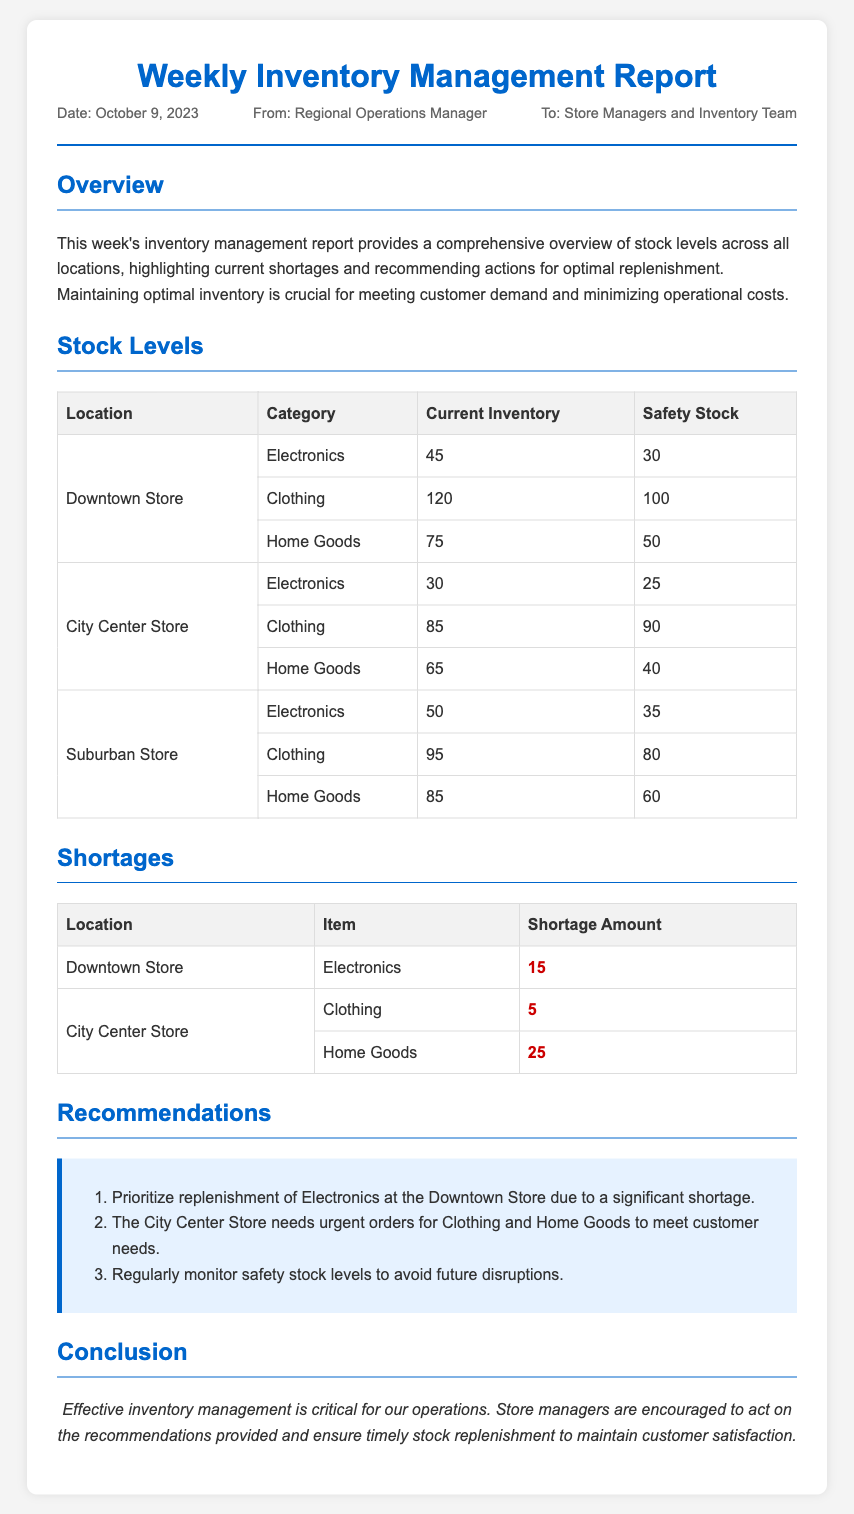What is the report date? The report date is mentioned in the memo under the meta section.
Answer: October 9, 2023 How many items are in stock for Clothing at the Downtown Store? The current inventory for Clothing at the Downtown Store is listed in the Stock Levels section.
Answer: 120 What is the shortage amount for Home Goods at the City Center Store? The shortage amount for Home Goods is specified in the Shortages section of the report.
Answer: 25 Which store has the highest current inventory for Electronics? This information can be deduced by comparing the current inventories listed in the Stock Levels section.
Answer: Suburban Store What should be prioritized for replenishment at the Downtown Store? This recommendation is provided in the Recommendations section of the report.
Answer: Electronics How many total locations are mentioned in the stock levels table? The locations are listed at the beginning of each row in the Stock Levels section, which can be counted.
Answer: 3 What are the two item shortages at the City Center Store? The specific items are named in the Shortages table under the City Center Store.
Answer: Clothing and Home Goods What is the overall purpose of this report? The purpose is outlined in the Overview section of the memo.
Answer: Comprehensive overview of stock levels How should managers respond to this report? This guidance is included in the Conclusion section of the document.
Answer: Act on recommendations 